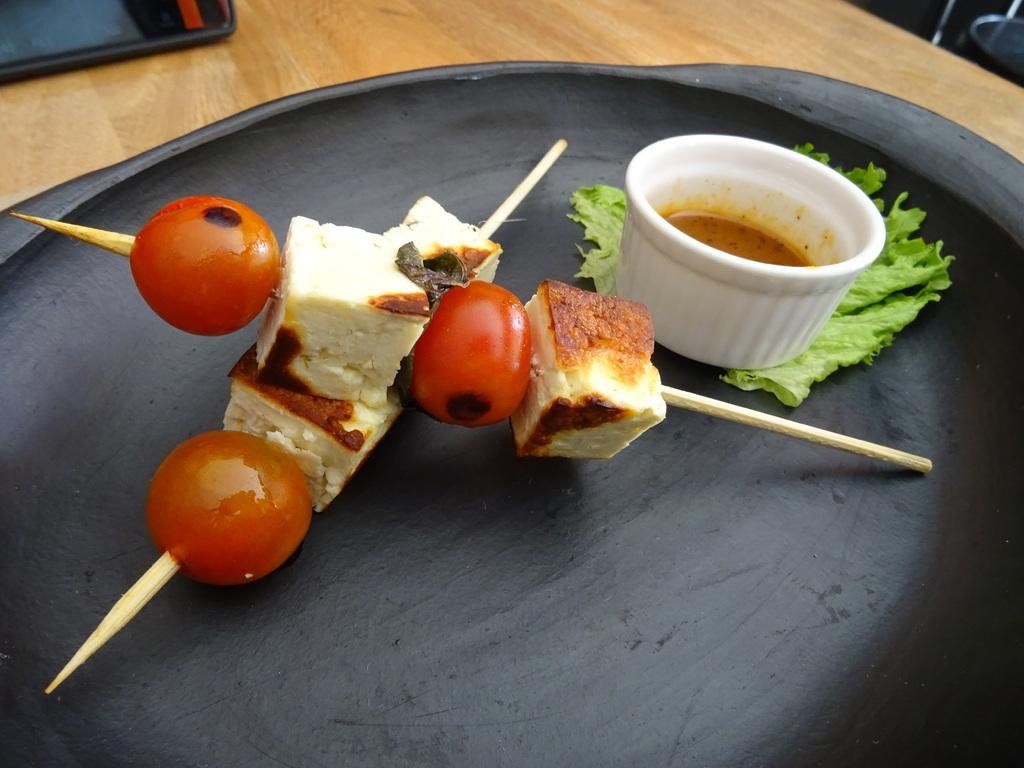What types of food are present in the image? There are tomato blocks and cheese blocks in the image. How are the tomato and cheese blocks arranged? The tomato and cheese blocks are arranged with sticks placed on them. What is the surface on which the tomato and cheese blocks are placed? The wooden table top is visible in the image. What type of flock can be seen flying over the tomato and cheese blocks in the image? There is no flock of birds or any other animals visible in the image. 